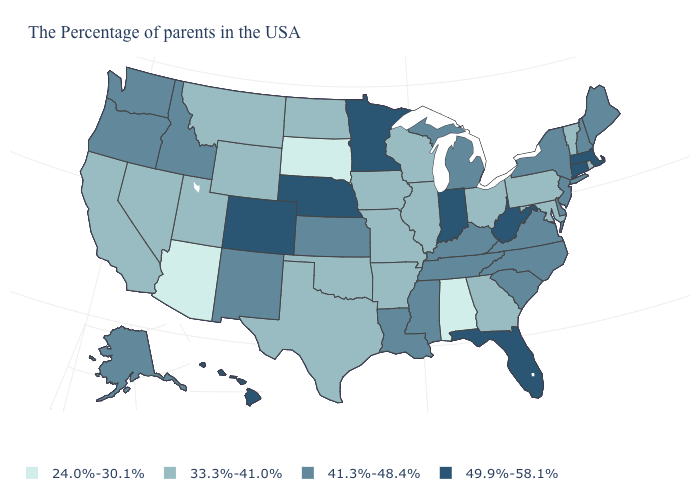Does Maryland have a lower value than Alabama?
Answer briefly. No. Does the first symbol in the legend represent the smallest category?
Short answer required. Yes. What is the value of Wyoming?
Quick response, please. 33.3%-41.0%. Does New York have the same value as Rhode Island?
Answer briefly. No. Name the states that have a value in the range 49.9%-58.1%?
Keep it brief. Massachusetts, Connecticut, West Virginia, Florida, Indiana, Minnesota, Nebraska, Colorado, Hawaii. What is the value of Wisconsin?
Concise answer only. 33.3%-41.0%. Name the states that have a value in the range 41.3%-48.4%?
Write a very short answer. Maine, New Hampshire, New York, New Jersey, Delaware, Virginia, North Carolina, South Carolina, Michigan, Kentucky, Tennessee, Mississippi, Louisiana, Kansas, New Mexico, Idaho, Washington, Oregon, Alaska. What is the value of New York?
Concise answer only. 41.3%-48.4%. Does the map have missing data?
Quick response, please. No. What is the value of North Carolina?
Keep it brief. 41.3%-48.4%. Which states have the lowest value in the South?
Keep it brief. Alabama. What is the highest value in the USA?
Concise answer only. 49.9%-58.1%. Does Kansas have a higher value than Tennessee?
Concise answer only. No. Is the legend a continuous bar?
Give a very brief answer. No. What is the lowest value in the USA?
Answer briefly. 24.0%-30.1%. 